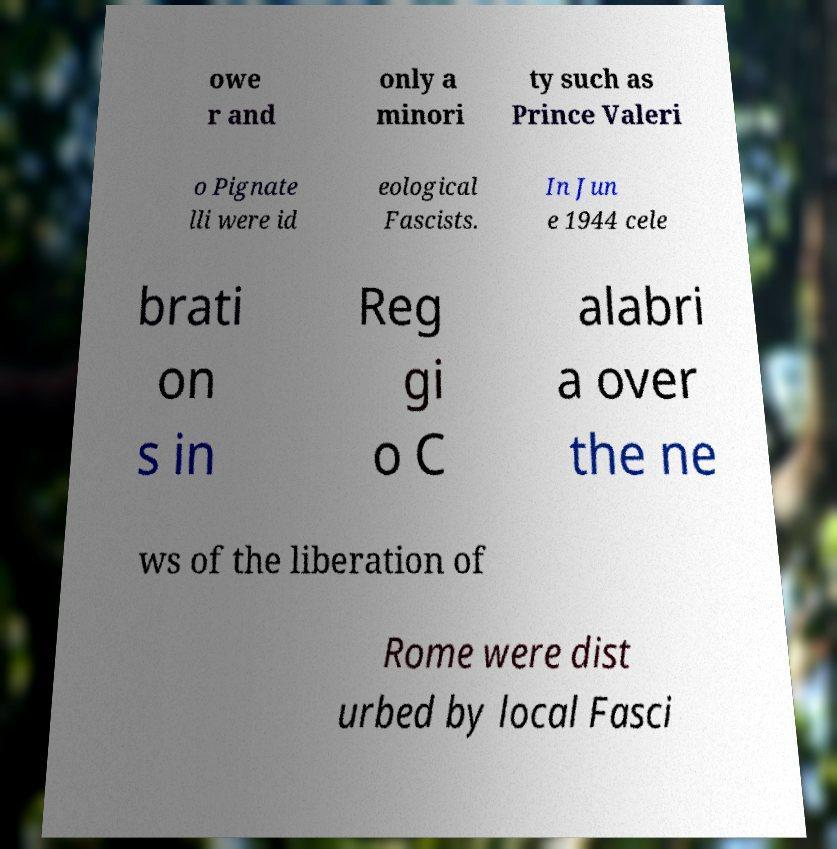Can you accurately transcribe the text from the provided image for me? owe r and only a minori ty such as Prince Valeri o Pignate lli were id eological Fascists. In Jun e 1944 cele brati on s in Reg gi o C alabri a over the ne ws of the liberation of Rome were dist urbed by local Fasci 